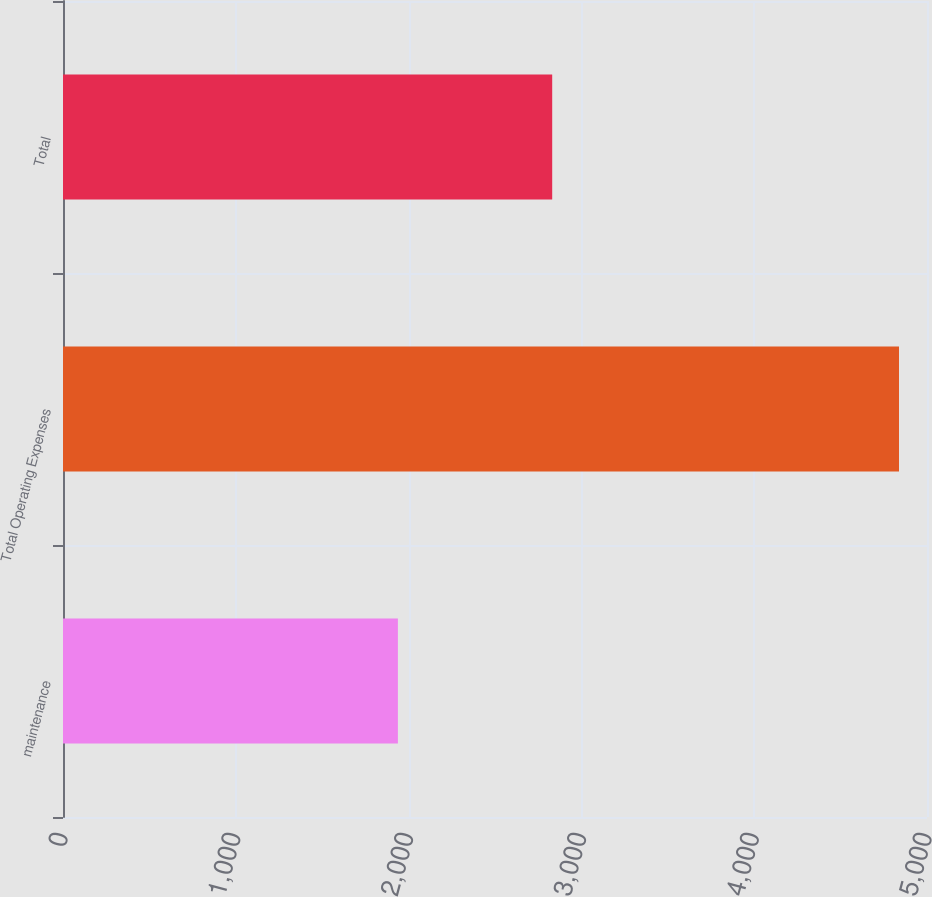Convert chart. <chart><loc_0><loc_0><loc_500><loc_500><bar_chart><fcel>maintenance<fcel>Total Operating Expenses<fcel>Total<nl><fcel>1938<fcel>4838<fcel>2831<nl></chart> 